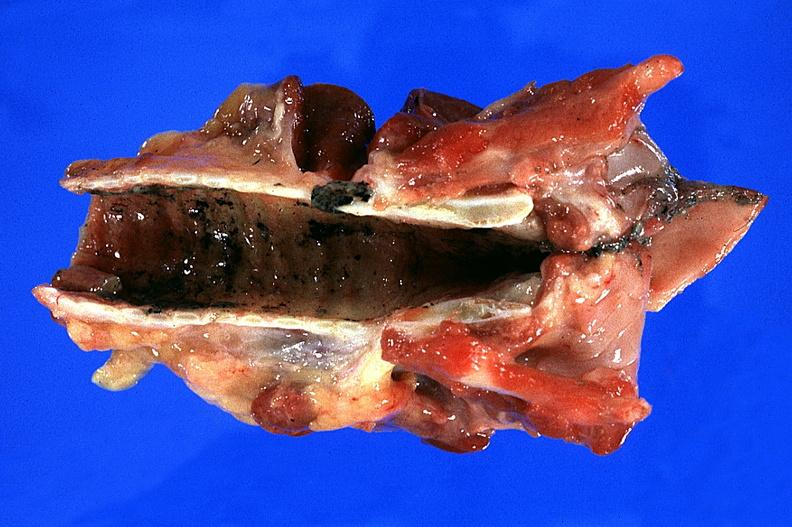do lip burn smoke inhalation?
Answer the question using a single word or phrase. No 